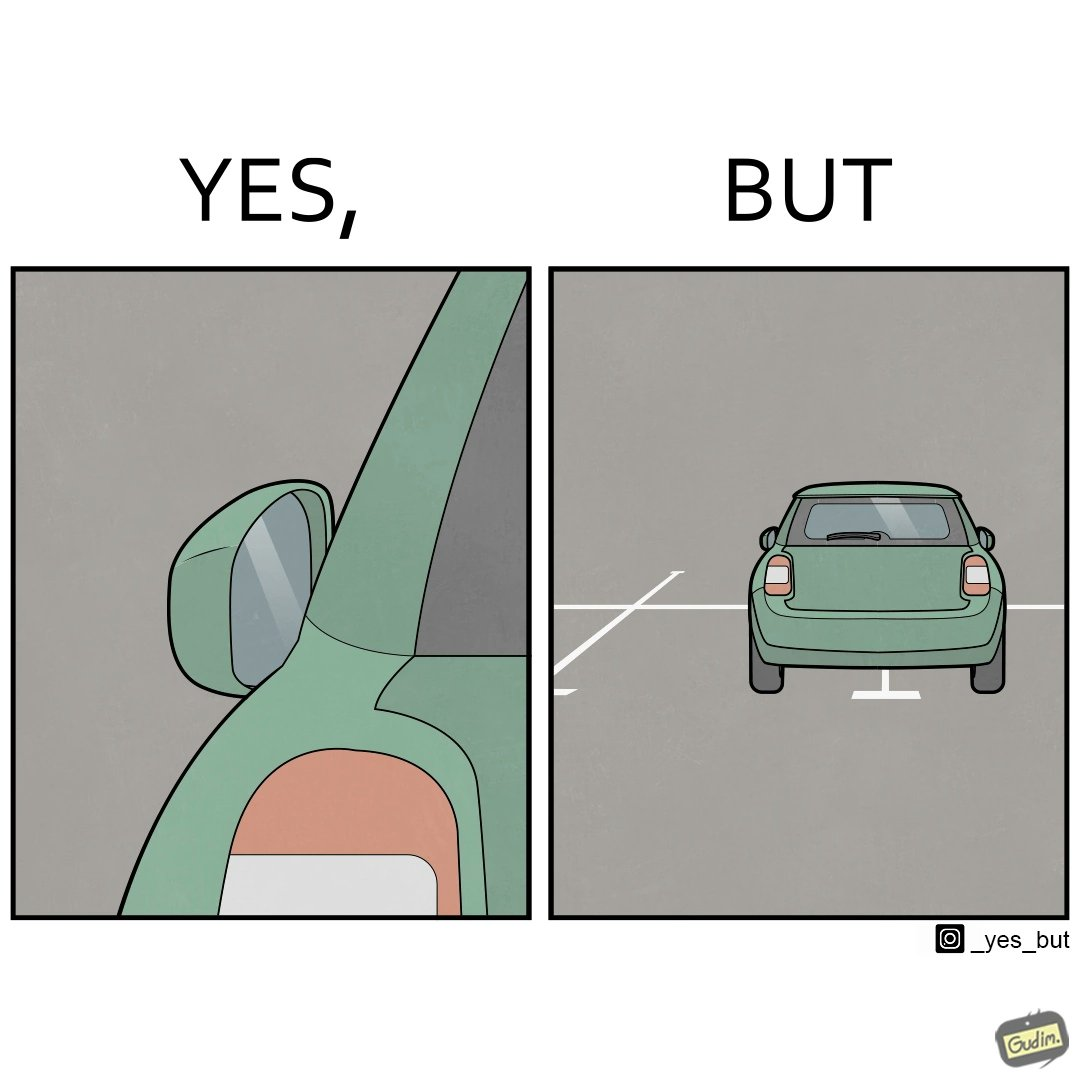Describe the contrast between the left and right parts of this image. In the left part of the image: The image shows a zoomed in image of a folded side mirror of a green car. In the right part of the image: The image shows a green car with both of its side mirrors folded. I car is parked improperly spanning accross two parking spots. 